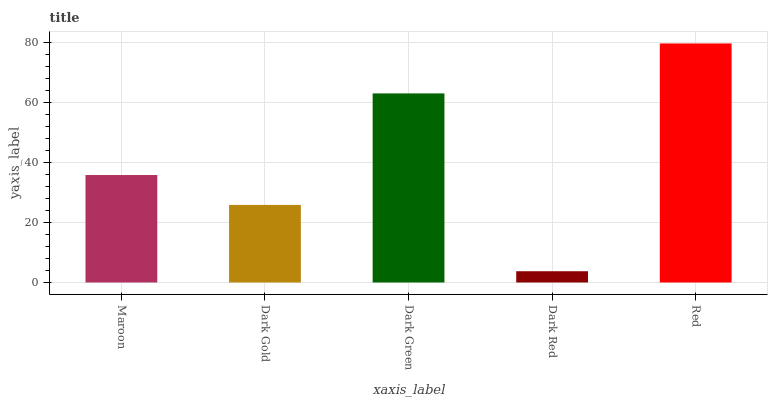Is Dark Red the minimum?
Answer yes or no. Yes. Is Red the maximum?
Answer yes or no. Yes. Is Dark Gold the minimum?
Answer yes or no. No. Is Dark Gold the maximum?
Answer yes or no. No. Is Maroon greater than Dark Gold?
Answer yes or no. Yes. Is Dark Gold less than Maroon?
Answer yes or no. Yes. Is Dark Gold greater than Maroon?
Answer yes or no. No. Is Maroon less than Dark Gold?
Answer yes or no. No. Is Maroon the high median?
Answer yes or no. Yes. Is Maroon the low median?
Answer yes or no. Yes. Is Red the high median?
Answer yes or no. No. Is Dark Red the low median?
Answer yes or no. No. 